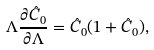Convert formula to latex. <formula><loc_0><loc_0><loc_500><loc_500>\Lambda \frac { \partial \hat { C } _ { 0 } } { \partial \Lambda } = \hat { C } _ { 0 } ( 1 + \hat { C } _ { 0 } ) ,</formula> 